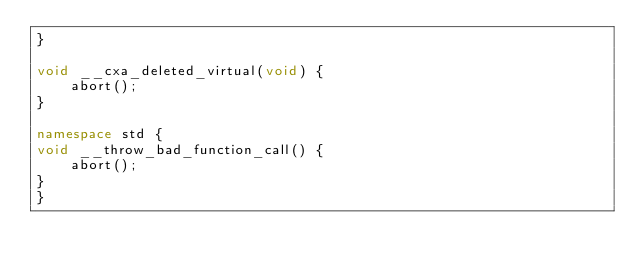<code> <loc_0><loc_0><loc_500><loc_500><_C++_>}

void __cxa_deleted_virtual(void) {
    abort();
}

namespace std {
void __throw_bad_function_call() {
    abort();
}
}
</code> 